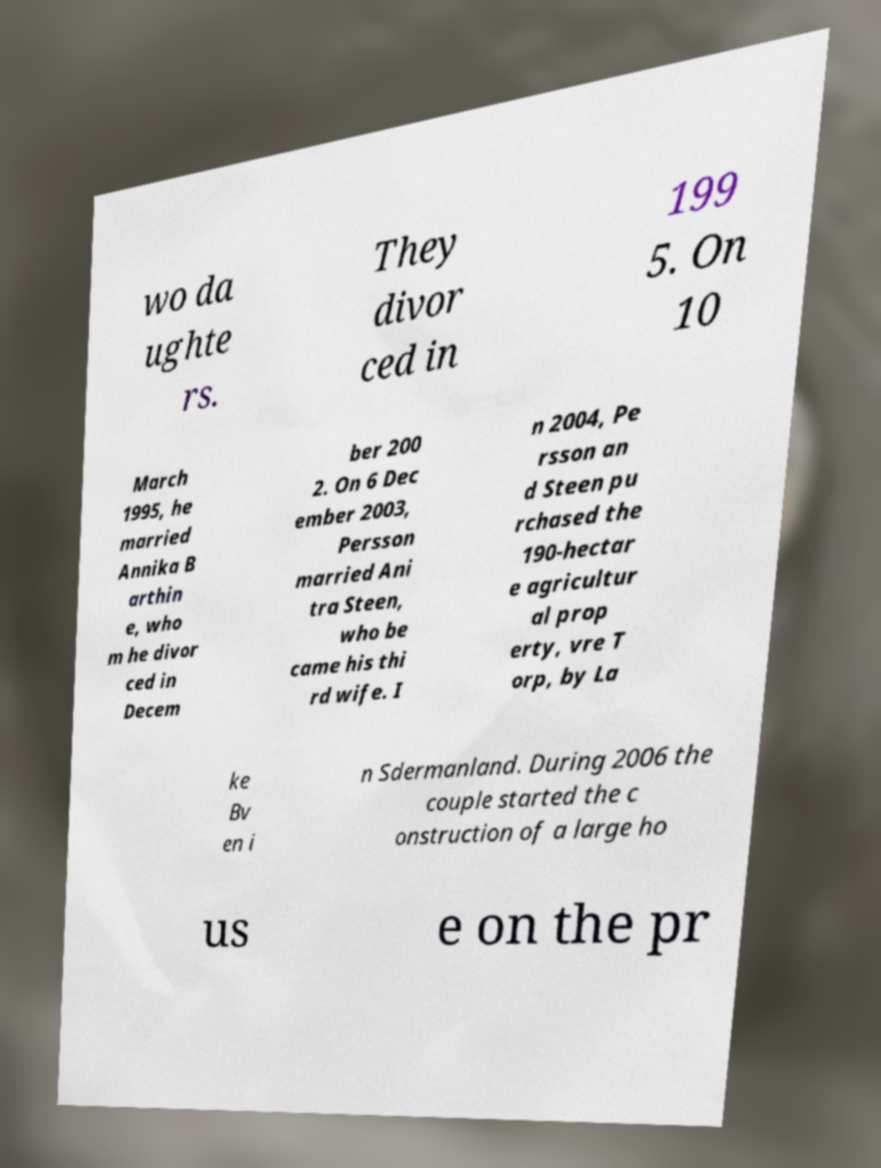Could you assist in decoding the text presented in this image and type it out clearly? wo da ughte rs. They divor ced in 199 5. On 10 March 1995, he married Annika B arthin e, who m he divor ced in Decem ber 200 2. On 6 Dec ember 2003, Persson married Ani tra Steen, who be came his thi rd wife. I n 2004, Pe rsson an d Steen pu rchased the 190-hectar e agricultur al prop erty, vre T orp, by La ke Bv en i n Sdermanland. During 2006 the couple started the c onstruction of a large ho us e on the pr 